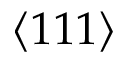Convert formula to latex. <formula><loc_0><loc_0><loc_500><loc_500>\langle 1 1 1 \rangle</formula> 